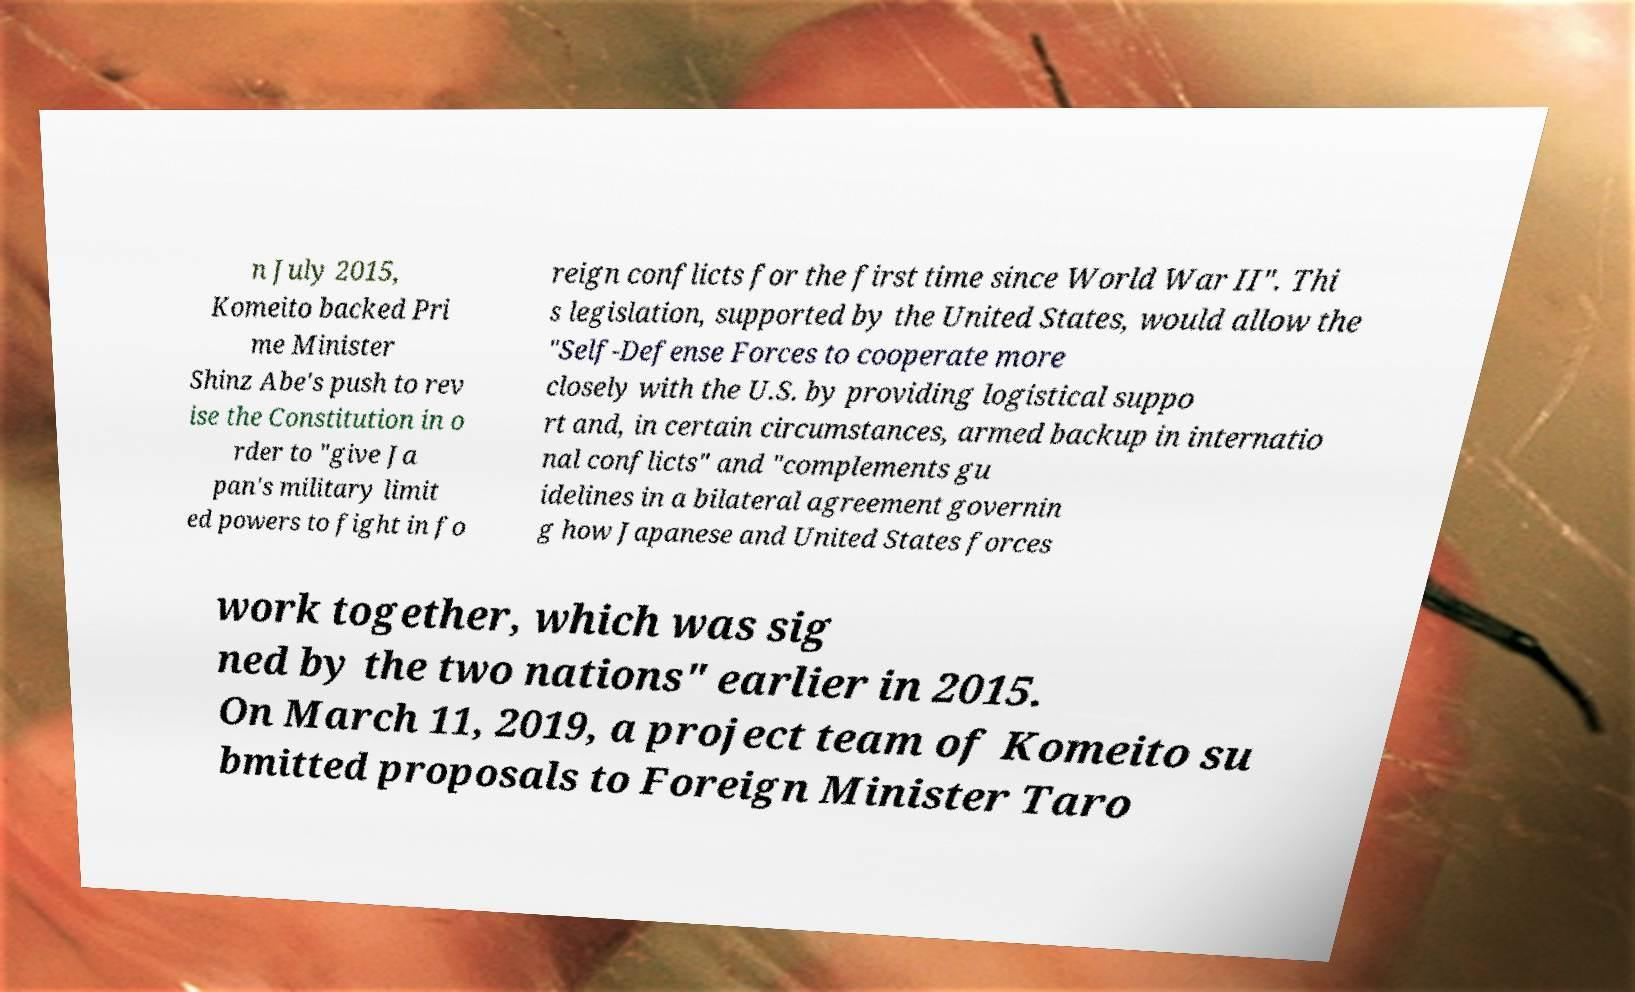Please identify and transcribe the text found in this image. n July 2015, Komeito backed Pri me Minister Shinz Abe's push to rev ise the Constitution in o rder to "give Ja pan's military limit ed powers to fight in fo reign conflicts for the first time since World War II". Thi s legislation, supported by the United States, would allow the "Self-Defense Forces to cooperate more closely with the U.S. by providing logistical suppo rt and, in certain circumstances, armed backup in internatio nal conflicts" and "complements gu idelines in a bilateral agreement governin g how Japanese and United States forces work together, which was sig ned by the two nations" earlier in 2015. On March 11, 2019, a project team of Komeito su bmitted proposals to Foreign Minister Taro 